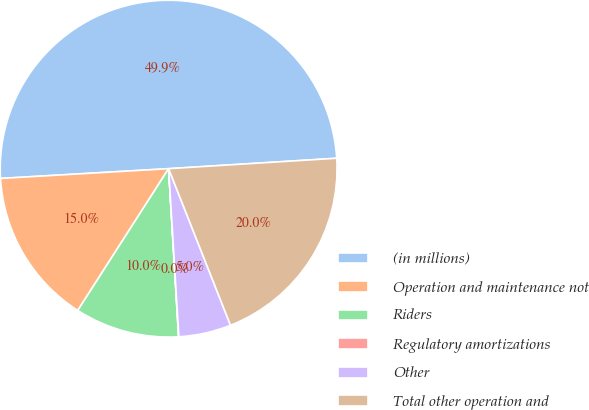Convert chart. <chart><loc_0><loc_0><loc_500><loc_500><pie_chart><fcel>(in millions)<fcel>Operation and maintenance not<fcel>Riders<fcel>Regulatory amortizations<fcel>Other<fcel>Total other operation and<nl><fcel>49.93%<fcel>15.0%<fcel>10.01%<fcel>0.03%<fcel>5.02%<fcel>19.99%<nl></chart> 